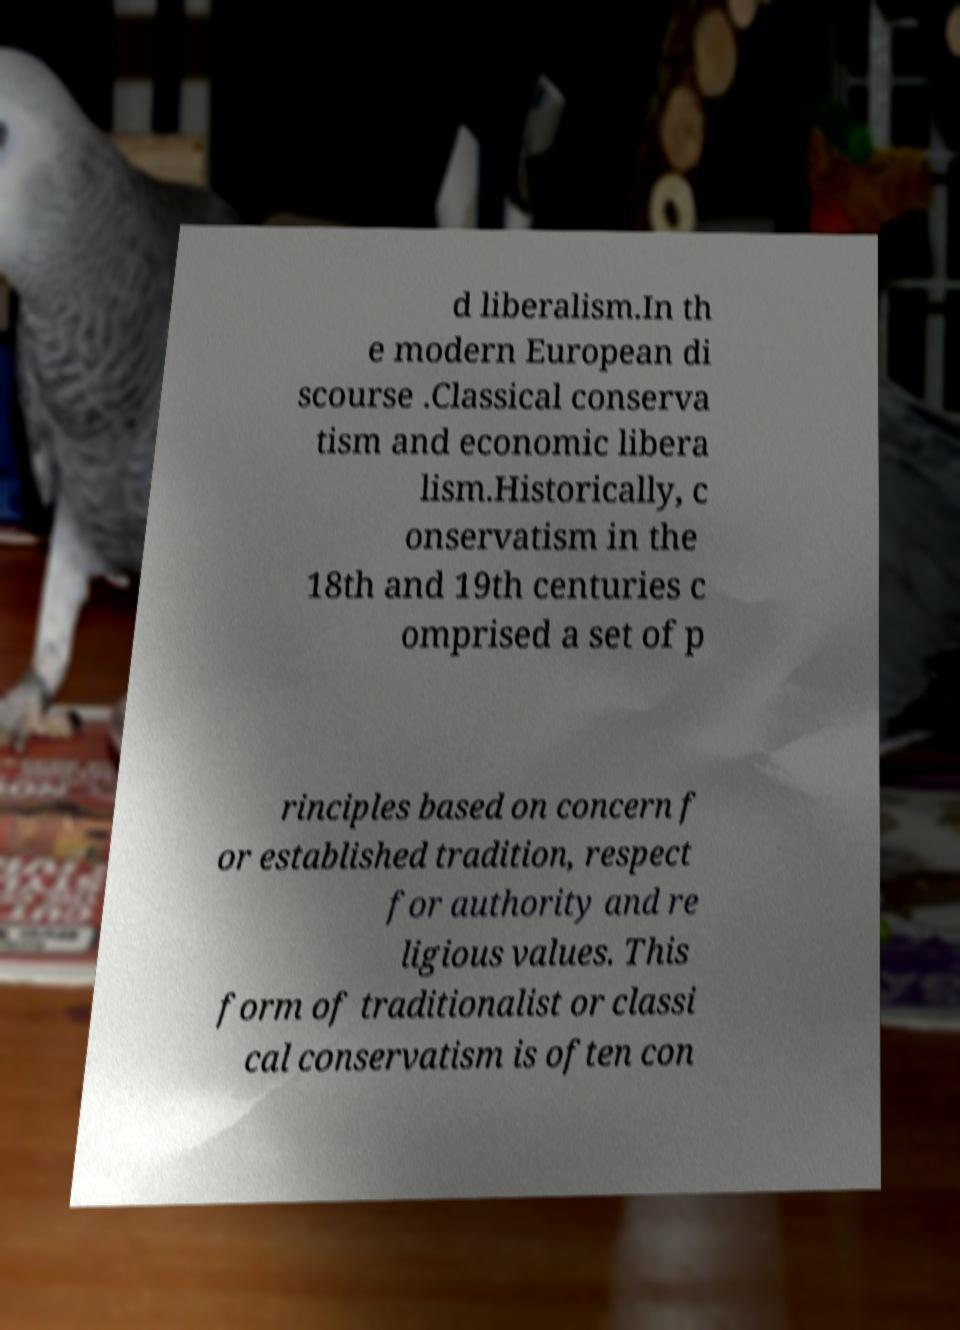I need the written content from this picture converted into text. Can you do that? d liberalism.In th e modern European di scourse .Classical conserva tism and economic libera lism.Historically, c onservatism in the 18th and 19th centuries c omprised a set of p rinciples based on concern f or established tradition, respect for authority and re ligious values. This form of traditionalist or classi cal conservatism is often con 